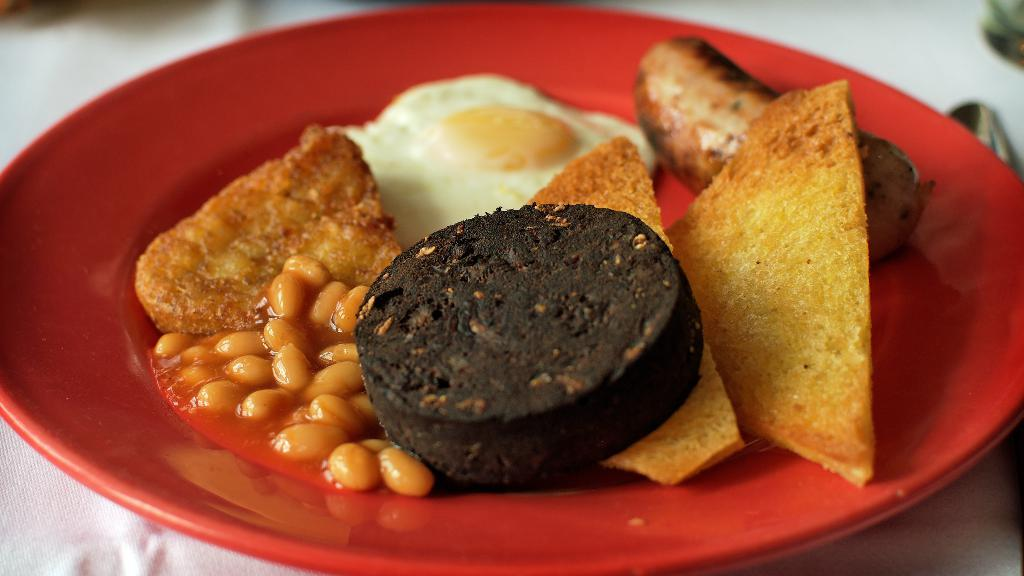What type of furniture is present in the image? There is a table in the image. What is placed on the table? There is a plate on the table. What food items can be seen on the plate? The plate contains an half boiled omelet, sausage, nachos, and biscuit. How many harbors can be seen in the image? There are no harbors present in the image. What type of earth is visible in the image? The image does not show any earth or soil; it features a table with a plate of food. 